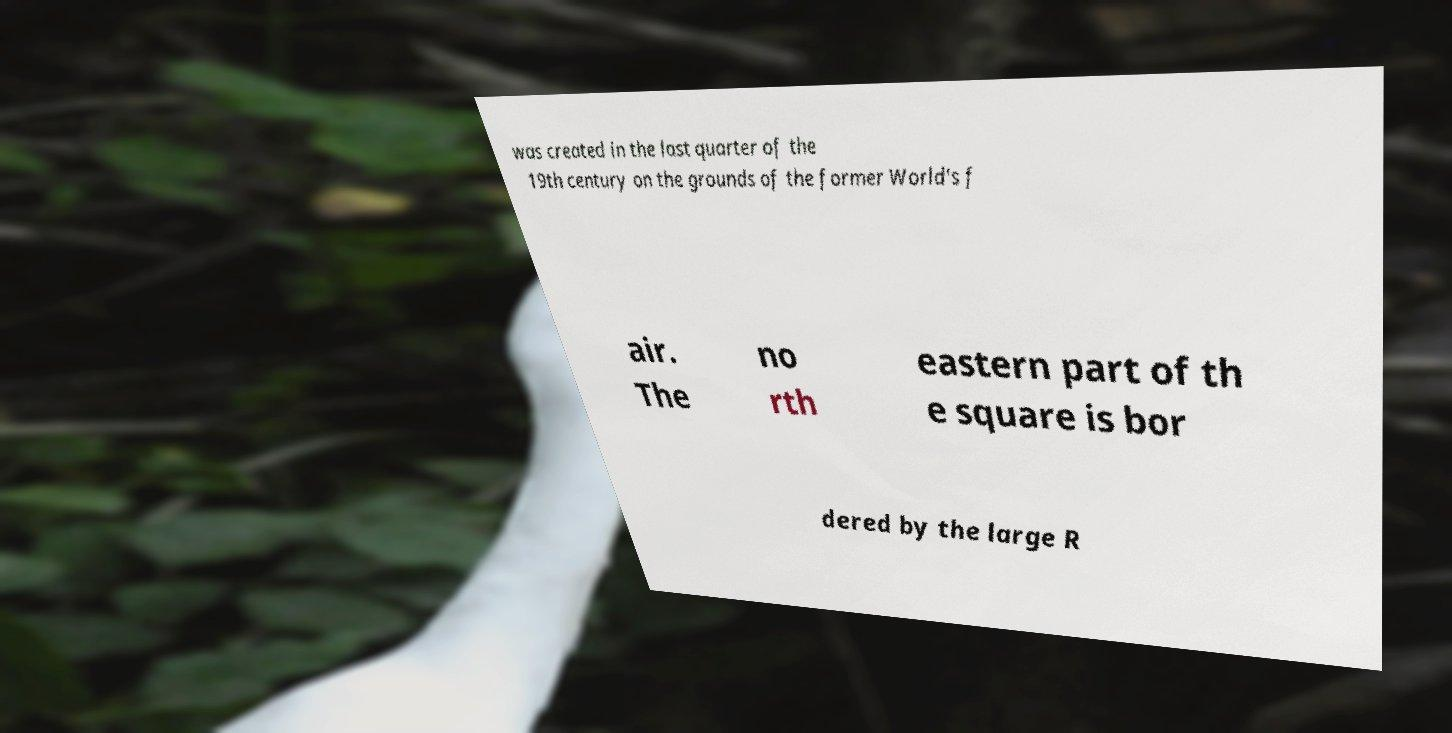I need the written content from this picture converted into text. Can you do that? was created in the last quarter of the 19th century on the grounds of the former World's f air. The no rth eastern part of th e square is bor dered by the large R 